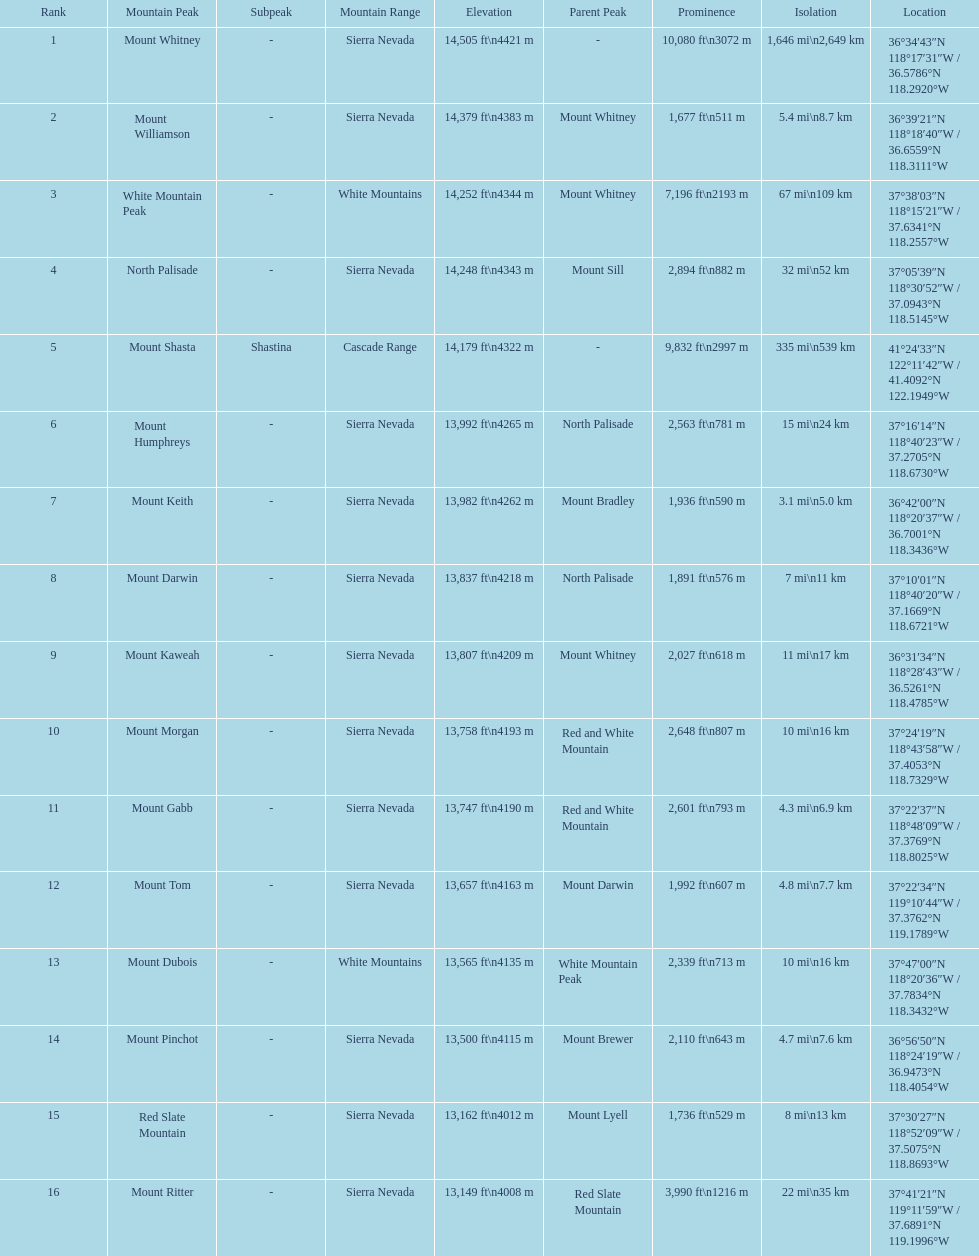Which mountain peak is the only mountain peak in the cascade range? Mount Shasta. 